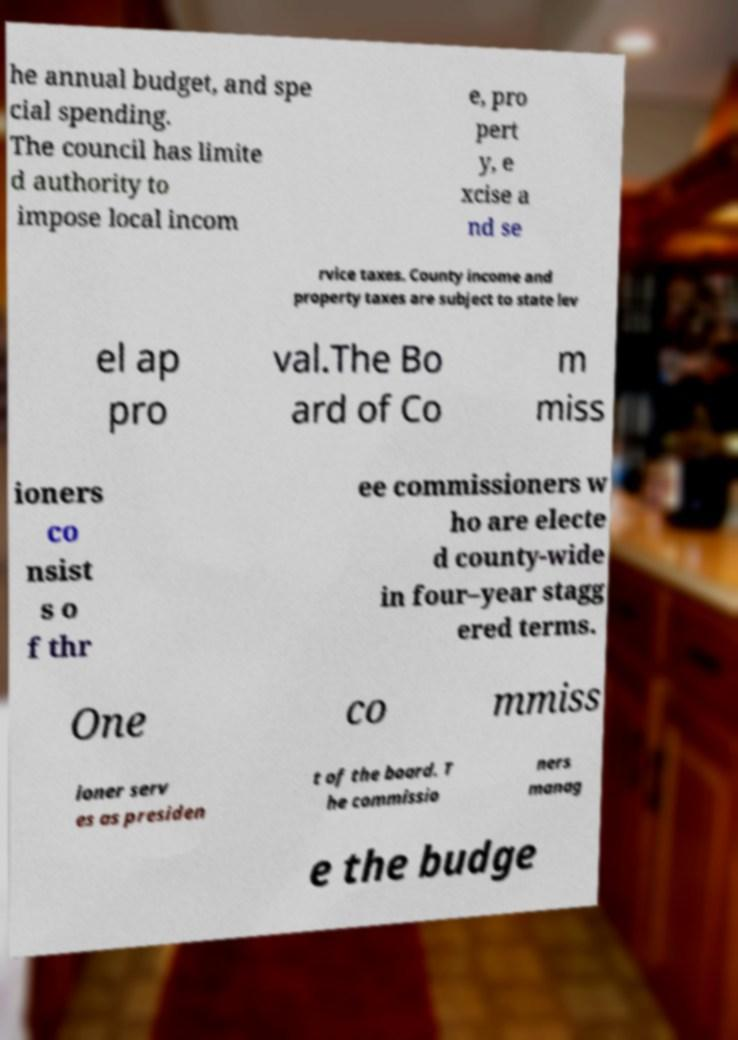Please identify and transcribe the text found in this image. he annual budget, and spe cial spending. The council has limite d authority to impose local incom e, pro pert y, e xcise a nd se rvice taxes. County income and property taxes are subject to state lev el ap pro val.The Bo ard of Co m miss ioners co nsist s o f thr ee commissioners w ho are electe d county-wide in four–year stagg ered terms. One co mmiss ioner serv es as presiden t of the board. T he commissio ners manag e the budge 